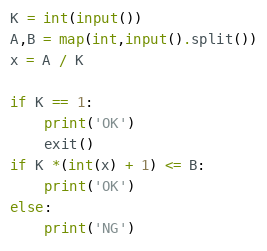Convert code to text. <code><loc_0><loc_0><loc_500><loc_500><_Python_>K = int(input())
A,B = map(int,input().split())
x = A / K

if K == 1:
    print('OK')
    exit()
if K *(int(x) + 1) <= B:
    print('OK')
else:
    print('NG')</code> 